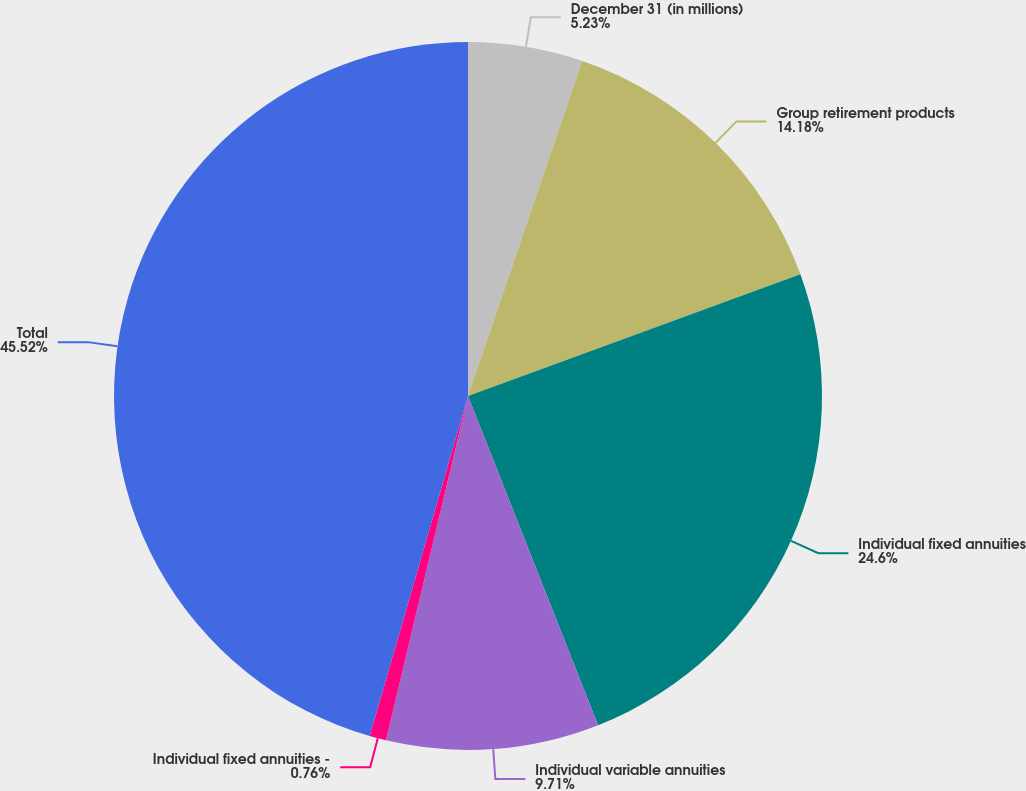Convert chart. <chart><loc_0><loc_0><loc_500><loc_500><pie_chart><fcel>December 31 (in millions)<fcel>Group retirement products<fcel>Individual fixed annuities<fcel>Individual variable annuities<fcel>Individual fixed annuities -<fcel>Total<nl><fcel>5.23%<fcel>14.18%<fcel>24.6%<fcel>9.71%<fcel>0.76%<fcel>45.52%<nl></chart> 